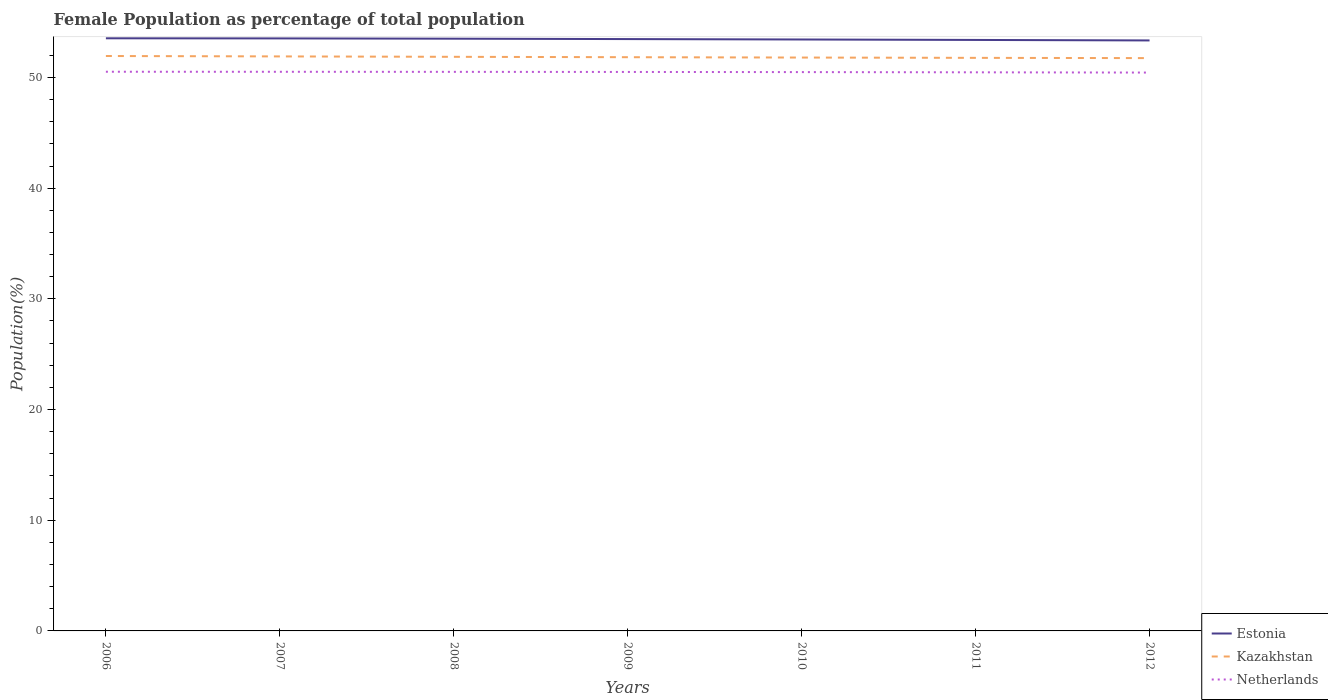How many different coloured lines are there?
Offer a very short reply. 3. Does the line corresponding to Netherlands intersect with the line corresponding to Estonia?
Make the answer very short. No. Is the number of lines equal to the number of legend labels?
Your answer should be compact. Yes. Across all years, what is the maximum female population in in Estonia?
Your response must be concise. 53.34. What is the total female population in in Estonia in the graph?
Keep it short and to the point. 0.12. What is the difference between the highest and the second highest female population in in Kazakhstan?
Keep it short and to the point. 0.19. Is the female population in in Estonia strictly greater than the female population in in Kazakhstan over the years?
Your answer should be compact. No. What is the difference between two consecutive major ticks on the Y-axis?
Offer a very short reply. 10. Are the values on the major ticks of Y-axis written in scientific E-notation?
Offer a very short reply. No. Does the graph contain any zero values?
Offer a very short reply. No. How are the legend labels stacked?
Provide a succinct answer. Vertical. What is the title of the graph?
Offer a very short reply. Female Population as percentage of total population. Does "Ireland" appear as one of the legend labels in the graph?
Keep it short and to the point. No. What is the label or title of the Y-axis?
Provide a short and direct response. Population(%). What is the Population(%) of Estonia in 2006?
Make the answer very short. 53.54. What is the Population(%) of Kazakhstan in 2006?
Keep it short and to the point. 51.94. What is the Population(%) in Netherlands in 2006?
Your response must be concise. 50.52. What is the Population(%) in Estonia in 2007?
Give a very brief answer. 53.53. What is the Population(%) in Kazakhstan in 2007?
Keep it short and to the point. 51.9. What is the Population(%) in Netherlands in 2007?
Keep it short and to the point. 50.51. What is the Population(%) in Estonia in 2008?
Give a very brief answer. 53.5. What is the Population(%) in Kazakhstan in 2008?
Ensure brevity in your answer.  51.86. What is the Population(%) in Netherlands in 2008?
Give a very brief answer. 50.51. What is the Population(%) of Estonia in 2009?
Make the answer very short. 53.47. What is the Population(%) in Kazakhstan in 2009?
Make the answer very short. 51.83. What is the Population(%) in Netherlands in 2009?
Your answer should be compact. 50.5. What is the Population(%) of Estonia in 2010?
Keep it short and to the point. 53.43. What is the Population(%) in Kazakhstan in 2010?
Your answer should be very brief. 51.8. What is the Population(%) of Netherlands in 2010?
Your response must be concise. 50.48. What is the Population(%) in Estonia in 2011?
Offer a very short reply. 53.39. What is the Population(%) in Kazakhstan in 2011?
Your answer should be compact. 51.77. What is the Population(%) in Netherlands in 2011?
Give a very brief answer. 50.46. What is the Population(%) in Estonia in 2012?
Keep it short and to the point. 53.34. What is the Population(%) in Kazakhstan in 2012?
Your answer should be very brief. 51.75. What is the Population(%) of Netherlands in 2012?
Your answer should be compact. 50.44. Across all years, what is the maximum Population(%) in Estonia?
Ensure brevity in your answer.  53.54. Across all years, what is the maximum Population(%) in Kazakhstan?
Give a very brief answer. 51.94. Across all years, what is the maximum Population(%) of Netherlands?
Keep it short and to the point. 50.52. Across all years, what is the minimum Population(%) in Estonia?
Make the answer very short. 53.34. Across all years, what is the minimum Population(%) in Kazakhstan?
Your answer should be compact. 51.75. Across all years, what is the minimum Population(%) in Netherlands?
Make the answer very short. 50.44. What is the total Population(%) of Estonia in the graph?
Your answer should be compact. 374.2. What is the total Population(%) of Kazakhstan in the graph?
Keep it short and to the point. 362.85. What is the total Population(%) of Netherlands in the graph?
Make the answer very short. 353.42. What is the difference between the Population(%) of Estonia in 2006 and that in 2007?
Ensure brevity in your answer.  0.01. What is the difference between the Population(%) of Kazakhstan in 2006 and that in 2007?
Give a very brief answer. 0.04. What is the difference between the Population(%) of Netherlands in 2006 and that in 2007?
Offer a terse response. 0. What is the difference between the Population(%) in Estonia in 2006 and that in 2008?
Provide a succinct answer. 0.04. What is the difference between the Population(%) in Kazakhstan in 2006 and that in 2008?
Offer a very short reply. 0.07. What is the difference between the Population(%) of Netherlands in 2006 and that in 2008?
Ensure brevity in your answer.  0.01. What is the difference between the Population(%) in Estonia in 2006 and that in 2009?
Your answer should be very brief. 0.07. What is the difference between the Population(%) in Kazakhstan in 2006 and that in 2009?
Make the answer very short. 0.11. What is the difference between the Population(%) in Netherlands in 2006 and that in 2009?
Your response must be concise. 0.02. What is the difference between the Population(%) of Estonia in 2006 and that in 2010?
Your answer should be very brief. 0.11. What is the difference between the Population(%) in Kazakhstan in 2006 and that in 2010?
Make the answer very short. 0.14. What is the difference between the Population(%) of Netherlands in 2006 and that in 2010?
Your answer should be compact. 0.03. What is the difference between the Population(%) in Estonia in 2006 and that in 2011?
Ensure brevity in your answer.  0.15. What is the difference between the Population(%) in Netherlands in 2006 and that in 2011?
Offer a very short reply. 0.05. What is the difference between the Population(%) in Estonia in 2006 and that in 2012?
Provide a succinct answer. 0.19. What is the difference between the Population(%) of Kazakhstan in 2006 and that in 2012?
Your answer should be very brief. 0.19. What is the difference between the Population(%) of Netherlands in 2006 and that in 2012?
Your response must be concise. 0.08. What is the difference between the Population(%) of Estonia in 2007 and that in 2008?
Give a very brief answer. 0.03. What is the difference between the Population(%) of Kazakhstan in 2007 and that in 2008?
Offer a very short reply. 0.04. What is the difference between the Population(%) in Netherlands in 2007 and that in 2008?
Ensure brevity in your answer.  0.01. What is the difference between the Population(%) in Estonia in 2007 and that in 2009?
Your response must be concise. 0.06. What is the difference between the Population(%) of Kazakhstan in 2007 and that in 2009?
Provide a short and direct response. 0.07. What is the difference between the Population(%) of Netherlands in 2007 and that in 2009?
Provide a succinct answer. 0.02. What is the difference between the Population(%) of Estonia in 2007 and that in 2010?
Make the answer very short. 0.1. What is the difference between the Population(%) of Kazakhstan in 2007 and that in 2010?
Provide a succinct answer. 0.1. What is the difference between the Population(%) in Netherlands in 2007 and that in 2010?
Keep it short and to the point. 0.03. What is the difference between the Population(%) of Estonia in 2007 and that in 2011?
Keep it short and to the point. 0.14. What is the difference between the Population(%) in Kazakhstan in 2007 and that in 2011?
Your answer should be very brief. 0.13. What is the difference between the Population(%) in Netherlands in 2007 and that in 2011?
Offer a terse response. 0.05. What is the difference between the Population(%) of Estonia in 2007 and that in 2012?
Your response must be concise. 0.18. What is the difference between the Population(%) in Kazakhstan in 2007 and that in 2012?
Give a very brief answer. 0.15. What is the difference between the Population(%) in Netherlands in 2007 and that in 2012?
Offer a very short reply. 0.07. What is the difference between the Population(%) of Estonia in 2008 and that in 2009?
Offer a very short reply. 0.03. What is the difference between the Population(%) in Kazakhstan in 2008 and that in 2009?
Provide a succinct answer. 0.03. What is the difference between the Population(%) of Netherlands in 2008 and that in 2009?
Give a very brief answer. 0.01. What is the difference between the Population(%) of Estonia in 2008 and that in 2010?
Make the answer very short. 0.07. What is the difference between the Population(%) in Kazakhstan in 2008 and that in 2010?
Give a very brief answer. 0.07. What is the difference between the Population(%) of Netherlands in 2008 and that in 2010?
Ensure brevity in your answer.  0.02. What is the difference between the Population(%) of Estonia in 2008 and that in 2011?
Provide a succinct answer. 0.11. What is the difference between the Population(%) of Kazakhstan in 2008 and that in 2011?
Your answer should be compact. 0.09. What is the difference between the Population(%) in Netherlands in 2008 and that in 2011?
Your response must be concise. 0.04. What is the difference between the Population(%) in Estonia in 2008 and that in 2012?
Offer a terse response. 0.16. What is the difference between the Population(%) of Kazakhstan in 2008 and that in 2012?
Keep it short and to the point. 0.12. What is the difference between the Population(%) of Netherlands in 2008 and that in 2012?
Make the answer very short. 0.07. What is the difference between the Population(%) in Estonia in 2009 and that in 2010?
Give a very brief answer. 0.04. What is the difference between the Population(%) in Kazakhstan in 2009 and that in 2010?
Provide a short and direct response. 0.03. What is the difference between the Population(%) of Netherlands in 2009 and that in 2010?
Your answer should be compact. 0.01. What is the difference between the Population(%) in Estonia in 2009 and that in 2011?
Ensure brevity in your answer.  0.08. What is the difference between the Population(%) in Kazakhstan in 2009 and that in 2011?
Offer a very short reply. 0.06. What is the difference between the Population(%) of Netherlands in 2009 and that in 2011?
Provide a succinct answer. 0.03. What is the difference between the Population(%) of Estonia in 2009 and that in 2012?
Provide a short and direct response. 0.12. What is the difference between the Population(%) in Kazakhstan in 2009 and that in 2012?
Offer a terse response. 0.08. What is the difference between the Population(%) of Netherlands in 2009 and that in 2012?
Your answer should be compact. 0.06. What is the difference between the Population(%) of Estonia in 2010 and that in 2011?
Provide a short and direct response. 0.04. What is the difference between the Population(%) in Kazakhstan in 2010 and that in 2011?
Offer a terse response. 0.03. What is the difference between the Population(%) of Netherlands in 2010 and that in 2011?
Your response must be concise. 0.02. What is the difference between the Population(%) in Estonia in 2010 and that in 2012?
Your answer should be compact. 0.08. What is the difference between the Population(%) of Kazakhstan in 2010 and that in 2012?
Make the answer very short. 0.05. What is the difference between the Population(%) in Netherlands in 2010 and that in 2012?
Your answer should be compact. 0.04. What is the difference between the Population(%) of Estonia in 2011 and that in 2012?
Provide a short and direct response. 0.04. What is the difference between the Population(%) of Kazakhstan in 2011 and that in 2012?
Keep it short and to the point. 0.02. What is the difference between the Population(%) of Netherlands in 2011 and that in 2012?
Give a very brief answer. 0.02. What is the difference between the Population(%) in Estonia in 2006 and the Population(%) in Kazakhstan in 2007?
Your answer should be compact. 1.64. What is the difference between the Population(%) in Estonia in 2006 and the Population(%) in Netherlands in 2007?
Make the answer very short. 3.03. What is the difference between the Population(%) of Kazakhstan in 2006 and the Population(%) of Netherlands in 2007?
Provide a succinct answer. 1.42. What is the difference between the Population(%) in Estonia in 2006 and the Population(%) in Kazakhstan in 2008?
Ensure brevity in your answer.  1.67. What is the difference between the Population(%) of Estonia in 2006 and the Population(%) of Netherlands in 2008?
Offer a terse response. 3.03. What is the difference between the Population(%) in Kazakhstan in 2006 and the Population(%) in Netherlands in 2008?
Offer a very short reply. 1.43. What is the difference between the Population(%) of Estonia in 2006 and the Population(%) of Kazakhstan in 2009?
Offer a terse response. 1.71. What is the difference between the Population(%) of Estonia in 2006 and the Population(%) of Netherlands in 2009?
Your answer should be very brief. 3.04. What is the difference between the Population(%) in Kazakhstan in 2006 and the Population(%) in Netherlands in 2009?
Provide a succinct answer. 1.44. What is the difference between the Population(%) in Estonia in 2006 and the Population(%) in Kazakhstan in 2010?
Provide a succinct answer. 1.74. What is the difference between the Population(%) in Estonia in 2006 and the Population(%) in Netherlands in 2010?
Make the answer very short. 3.05. What is the difference between the Population(%) of Kazakhstan in 2006 and the Population(%) of Netherlands in 2010?
Give a very brief answer. 1.45. What is the difference between the Population(%) in Estonia in 2006 and the Population(%) in Kazakhstan in 2011?
Give a very brief answer. 1.77. What is the difference between the Population(%) of Estonia in 2006 and the Population(%) of Netherlands in 2011?
Keep it short and to the point. 3.07. What is the difference between the Population(%) of Kazakhstan in 2006 and the Population(%) of Netherlands in 2011?
Your answer should be very brief. 1.47. What is the difference between the Population(%) of Estonia in 2006 and the Population(%) of Kazakhstan in 2012?
Keep it short and to the point. 1.79. What is the difference between the Population(%) of Estonia in 2006 and the Population(%) of Netherlands in 2012?
Keep it short and to the point. 3.1. What is the difference between the Population(%) in Kazakhstan in 2006 and the Population(%) in Netherlands in 2012?
Make the answer very short. 1.5. What is the difference between the Population(%) in Estonia in 2007 and the Population(%) in Kazakhstan in 2008?
Your response must be concise. 1.66. What is the difference between the Population(%) in Estonia in 2007 and the Population(%) in Netherlands in 2008?
Offer a very short reply. 3.02. What is the difference between the Population(%) in Kazakhstan in 2007 and the Population(%) in Netherlands in 2008?
Offer a terse response. 1.39. What is the difference between the Population(%) of Estonia in 2007 and the Population(%) of Kazakhstan in 2009?
Your response must be concise. 1.7. What is the difference between the Population(%) of Estonia in 2007 and the Population(%) of Netherlands in 2009?
Make the answer very short. 3.03. What is the difference between the Population(%) of Kazakhstan in 2007 and the Population(%) of Netherlands in 2009?
Keep it short and to the point. 1.4. What is the difference between the Population(%) of Estonia in 2007 and the Population(%) of Kazakhstan in 2010?
Keep it short and to the point. 1.73. What is the difference between the Population(%) in Estonia in 2007 and the Population(%) in Netherlands in 2010?
Provide a succinct answer. 3.04. What is the difference between the Population(%) of Kazakhstan in 2007 and the Population(%) of Netherlands in 2010?
Your response must be concise. 1.42. What is the difference between the Population(%) of Estonia in 2007 and the Population(%) of Kazakhstan in 2011?
Your answer should be compact. 1.76. What is the difference between the Population(%) in Estonia in 2007 and the Population(%) in Netherlands in 2011?
Give a very brief answer. 3.06. What is the difference between the Population(%) of Kazakhstan in 2007 and the Population(%) of Netherlands in 2011?
Give a very brief answer. 1.44. What is the difference between the Population(%) in Estonia in 2007 and the Population(%) in Kazakhstan in 2012?
Give a very brief answer. 1.78. What is the difference between the Population(%) in Estonia in 2007 and the Population(%) in Netherlands in 2012?
Your response must be concise. 3.09. What is the difference between the Population(%) in Kazakhstan in 2007 and the Population(%) in Netherlands in 2012?
Provide a succinct answer. 1.46. What is the difference between the Population(%) in Estonia in 2008 and the Population(%) in Kazakhstan in 2009?
Offer a very short reply. 1.67. What is the difference between the Population(%) of Estonia in 2008 and the Population(%) of Netherlands in 2009?
Your response must be concise. 3. What is the difference between the Population(%) of Kazakhstan in 2008 and the Population(%) of Netherlands in 2009?
Make the answer very short. 1.37. What is the difference between the Population(%) in Estonia in 2008 and the Population(%) in Kazakhstan in 2010?
Provide a short and direct response. 1.7. What is the difference between the Population(%) of Estonia in 2008 and the Population(%) of Netherlands in 2010?
Your answer should be compact. 3.02. What is the difference between the Population(%) of Kazakhstan in 2008 and the Population(%) of Netherlands in 2010?
Make the answer very short. 1.38. What is the difference between the Population(%) in Estonia in 2008 and the Population(%) in Kazakhstan in 2011?
Your answer should be very brief. 1.73. What is the difference between the Population(%) of Estonia in 2008 and the Population(%) of Netherlands in 2011?
Make the answer very short. 3.04. What is the difference between the Population(%) in Kazakhstan in 2008 and the Population(%) in Netherlands in 2011?
Give a very brief answer. 1.4. What is the difference between the Population(%) of Estonia in 2008 and the Population(%) of Kazakhstan in 2012?
Offer a terse response. 1.75. What is the difference between the Population(%) in Estonia in 2008 and the Population(%) in Netherlands in 2012?
Offer a very short reply. 3.06. What is the difference between the Population(%) in Kazakhstan in 2008 and the Population(%) in Netherlands in 2012?
Provide a short and direct response. 1.42. What is the difference between the Population(%) in Estonia in 2009 and the Population(%) in Kazakhstan in 2010?
Offer a terse response. 1.67. What is the difference between the Population(%) of Estonia in 2009 and the Population(%) of Netherlands in 2010?
Make the answer very short. 2.98. What is the difference between the Population(%) of Kazakhstan in 2009 and the Population(%) of Netherlands in 2010?
Make the answer very short. 1.35. What is the difference between the Population(%) in Estonia in 2009 and the Population(%) in Kazakhstan in 2011?
Provide a succinct answer. 1.7. What is the difference between the Population(%) in Estonia in 2009 and the Population(%) in Netherlands in 2011?
Your answer should be compact. 3. What is the difference between the Population(%) of Kazakhstan in 2009 and the Population(%) of Netherlands in 2011?
Your answer should be very brief. 1.37. What is the difference between the Population(%) in Estonia in 2009 and the Population(%) in Kazakhstan in 2012?
Give a very brief answer. 1.72. What is the difference between the Population(%) of Estonia in 2009 and the Population(%) of Netherlands in 2012?
Give a very brief answer. 3.03. What is the difference between the Population(%) in Kazakhstan in 2009 and the Population(%) in Netherlands in 2012?
Give a very brief answer. 1.39. What is the difference between the Population(%) of Estonia in 2010 and the Population(%) of Kazakhstan in 2011?
Provide a succinct answer. 1.66. What is the difference between the Population(%) of Estonia in 2010 and the Population(%) of Netherlands in 2011?
Make the answer very short. 2.96. What is the difference between the Population(%) in Kazakhstan in 2010 and the Population(%) in Netherlands in 2011?
Make the answer very short. 1.33. What is the difference between the Population(%) in Estonia in 2010 and the Population(%) in Kazakhstan in 2012?
Your response must be concise. 1.68. What is the difference between the Population(%) of Estonia in 2010 and the Population(%) of Netherlands in 2012?
Ensure brevity in your answer.  2.99. What is the difference between the Population(%) in Kazakhstan in 2010 and the Population(%) in Netherlands in 2012?
Offer a very short reply. 1.36. What is the difference between the Population(%) of Estonia in 2011 and the Population(%) of Kazakhstan in 2012?
Keep it short and to the point. 1.64. What is the difference between the Population(%) in Estonia in 2011 and the Population(%) in Netherlands in 2012?
Offer a very short reply. 2.95. What is the difference between the Population(%) in Kazakhstan in 2011 and the Population(%) in Netherlands in 2012?
Your answer should be very brief. 1.33. What is the average Population(%) of Estonia per year?
Make the answer very short. 53.46. What is the average Population(%) of Kazakhstan per year?
Provide a short and direct response. 51.84. What is the average Population(%) in Netherlands per year?
Keep it short and to the point. 50.49. In the year 2006, what is the difference between the Population(%) of Estonia and Population(%) of Kazakhstan?
Offer a terse response. 1.6. In the year 2006, what is the difference between the Population(%) of Estonia and Population(%) of Netherlands?
Your response must be concise. 3.02. In the year 2006, what is the difference between the Population(%) of Kazakhstan and Population(%) of Netherlands?
Your answer should be very brief. 1.42. In the year 2007, what is the difference between the Population(%) of Estonia and Population(%) of Kazakhstan?
Offer a very short reply. 1.63. In the year 2007, what is the difference between the Population(%) of Estonia and Population(%) of Netherlands?
Provide a succinct answer. 3.01. In the year 2007, what is the difference between the Population(%) of Kazakhstan and Population(%) of Netherlands?
Offer a terse response. 1.39. In the year 2008, what is the difference between the Population(%) in Estonia and Population(%) in Kazakhstan?
Provide a succinct answer. 1.64. In the year 2008, what is the difference between the Population(%) of Estonia and Population(%) of Netherlands?
Give a very brief answer. 2.99. In the year 2008, what is the difference between the Population(%) of Kazakhstan and Population(%) of Netherlands?
Provide a succinct answer. 1.36. In the year 2009, what is the difference between the Population(%) of Estonia and Population(%) of Kazakhstan?
Provide a succinct answer. 1.64. In the year 2009, what is the difference between the Population(%) of Estonia and Population(%) of Netherlands?
Keep it short and to the point. 2.97. In the year 2009, what is the difference between the Population(%) of Kazakhstan and Population(%) of Netherlands?
Offer a very short reply. 1.33. In the year 2010, what is the difference between the Population(%) of Estonia and Population(%) of Kazakhstan?
Offer a very short reply. 1.63. In the year 2010, what is the difference between the Population(%) of Estonia and Population(%) of Netherlands?
Your answer should be compact. 2.95. In the year 2010, what is the difference between the Population(%) of Kazakhstan and Population(%) of Netherlands?
Your response must be concise. 1.31. In the year 2011, what is the difference between the Population(%) of Estonia and Population(%) of Kazakhstan?
Keep it short and to the point. 1.62. In the year 2011, what is the difference between the Population(%) of Estonia and Population(%) of Netherlands?
Offer a very short reply. 2.92. In the year 2011, what is the difference between the Population(%) in Kazakhstan and Population(%) in Netherlands?
Ensure brevity in your answer.  1.31. In the year 2012, what is the difference between the Population(%) of Estonia and Population(%) of Kazakhstan?
Give a very brief answer. 1.6. In the year 2012, what is the difference between the Population(%) of Estonia and Population(%) of Netherlands?
Offer a very short reply. 2.9. In the year 2012, what is the difference between the Population(%) in Kazakhstan and Population(%) in Netherlands?
Ensure brevity in your answer.  1.31. What is the ratio of the Population(%) of Kazakhstan in 2006 to that in 2008?
Offer a very short reply. 1. What is the ratio of the Population(%) of Netherlands in 2006 to that in 2008?
Offer a terse response. 1. What is the ratio of the Population(%) of Netherlands in 2006 to that in 2009?
Your response must be concise. 1. What is the ratio of the Population(%) of Estonia in 2006 to that in 2011?
Your answer should be very brief. 1. What is the ratio of the Population(%) of Netherlands in 2006 to that in 2011?
Keep it short and to the point. 1. What is the ratio of the Population(%) in Estonia in 2006 to that in 2012?
Provide a short and direct response. 1. What is the ratio of the Population(%) of Netherlands in 2007 to that in 2008?
Your answer should be compact. 1. What is the ratio of the Population(%) in Estonia in 2007 to that in 2009?
Ensure brevity in your answer.  1. What is the ratio of the Population(%) in Estonia in 2007 to that in 2010?
Provide a short and direct response. 1. What is the ratio of the Population(%) in Netherlands in 2007 to that in 2010?
Your answer should be very brief. 1. What is the ratio of the Population(%) in Estonia in 2007 to that in 2011?
Offer a very short reply. 1. What is the ratio of the Population(%) of Kazakhstan in 2007 to that in 2012?
Give a very brief answer. 1. What is the ratio of the Population(%) of Netherlands in 2007 to that in 2012?
Provide a succinct answer. 1. What is the ratio of the Population(%) of Estonia in 2008 to that in 2010?
Give a very brief answer. 1. What is the ratio of the Population(%) of Kazakhstan in 2008 to that in 2010?
Offer a terse response. 1. What is the ratio of the Population(%) in Estonia in 2008 to that in 2011?
Provide a short and direct response. 1. What is the ratio of the Population(%) in Kazakhstan in 2008 to that in 2011?
Give a very brief answer. 1. What is the ratio of the Population(%) of Kazakhstan in 2008 to that in 2012?
Offer a very short reply. 1. What is the ratio of the Population(%) of Netherlands in 2008 to that in 2012?
Your response must be concise. 1. What is the ratio of the Population(%) in Estonia in 2009 to that in 2010?
Your response must be concise. 1. What is the ratio of the Population(%) in Netherlands in 2009 to that in 2011?
Give a very brief answer. 1. What is the ratio of the Population(%) in Estonia in 2010 to that in 2011?
Offer a terse response. 1. What is the ratio of the Population(%) of Estonia in 2010 to that in 2012?
Offer a very short reply. 1. What is the ratio of the Population(%) of Kazakhstan in 2010 to that in 2012?
Offer a terse response. 1. What is the ratio of the Population(%) of Netherlands in 2010 to that in 2012?
Offer a terse response. 1. What is the ratio of the Population(%) of Estonia in 2011 to that in 2012?
Your answer should be very brief. 1. What is the ratio of the Population(%) of Kazakhstan in 2011 to that in 2012?
Your answer should be compact. 1. What is the ratio of the Population(%) of Netherlands in 2011 to that in 2012?
Offer a terse response. 1. What is the difference between the highest and the second highest Population(%) of Estonia?
Offer a very short reply. 0.01. What is the difference between the highest and the second highest Population(%) of Kazakhstan?
Offer a very short reply. 0.04. What is the difference between the highest and the second highest Population(%) in Netherlands?
Your answer should be compact. 0. What is the difference between the highest and the lowest Population(%) in Estonia?
Your response must be concise. 0.19. What is the difference between the highest and the lowest Population(%) in Kazakhstan?
Provide a short and direct response. 0.19. What is the difference between the highest and the lowest Population(%) of Netherlands?
Offer a terse response. 0.08. 